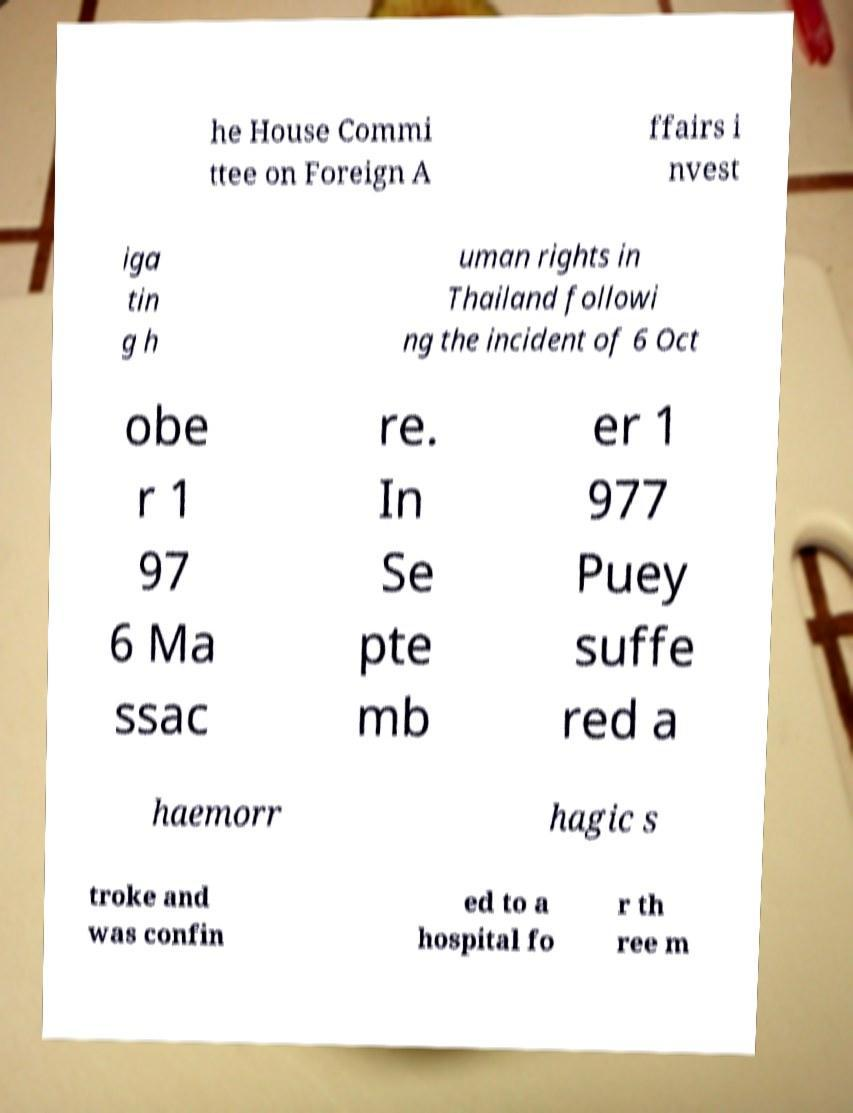What messages or text are displayed in this image? I need them in a readable, typed format. he House Commi ttee on Foreign A ffairs i nvest iga tin g h uman rights in Thailand followi ng the incident of 6 Oct obe r 1 97 6 Ma ssac re. In Se pte mb er 1 977 Puey suffe red a haemorr hagic s troke and was confin ed to a hospital fo r th ree m 